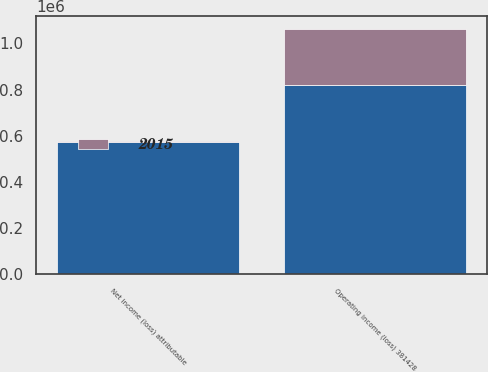Convert chart. <chart><loc_0><loc_0><loc_500><loc_500><stacked_bar_chart><ecel><fcel>Operating income (loss) 381428<fcel>Net income (loss) attributable<nl><fcel>nan<fcel>819156<fcel>571332<nl><fcel>2015<fcel>244935<fcel>6000<nl></chart> 